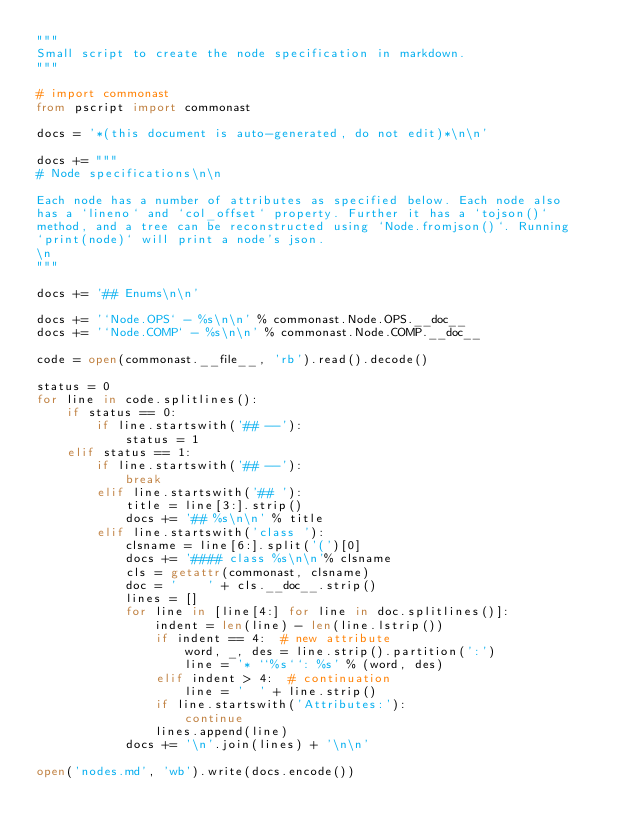Convert code to text. <code><loc_0><loc_0><loc_500><loc_500><_Python_>"""
Small script to create the node specification in markdown.
"""

# import commonast
from pscript import commonast

docs = '*(this document is auto-generated, do not edit)*\n\n'

docs += """
# Node specifications\n\n

Each node has a number of attributes as specified below. Each node also
has a `lineno` and `col_offset` property. Further it has a `tojson()`
method, and a tree can be reconstructed using `Node.fromjson()`. Running
`print(node)` will print a node's json.
\n
"""

docs += '## Enums\n\n'

docs += '`Node.OPS` - %s\n\n' % commonast.Node.OPS.__doc__
docs += '`Node.COMP` - %s\n\n' % commonast.Node.COMP.__doc__

code = open(commonast.__file__, 'rb').read().decode()

status = 0
for line in code.splitlines():
    if status == 0:
        if line.startswith('## --'):
            status = 1
    elif status == 1:
        if line.startswith('## --'):
            break
        elif line.startswith('## '):
            title = line[3:].strip()
            docs += '## %s\n\n' % title
        elif line.startswith('class '):
            clsname = line[6:].split('(')[0]
            docs += '#### class %s\n\n'% clsname
            cls = getattr(commonast, clsname)
            doc = '    ' + cls.__doc__.strip()
            lines = []
            for line in [line[4:] for line in doc.splitlines()]:
                indent = len(line) - len(line.lstrip())
                if indent == 4:  # new attribute
                    word, _, des = line.strip().partition(':')
                    line = '* ``%s``: %s' % (word, des)
                elif indent > 4:  # continuation
                    line = '  ' + line.strip()
                if line.startswith('Attributes:'):
                    continue
                lines.append(line)
            docs += '\n'.join(lines) + '\n\n'

open('nodes.md', 'wb').write(docs.encode())
</code> 